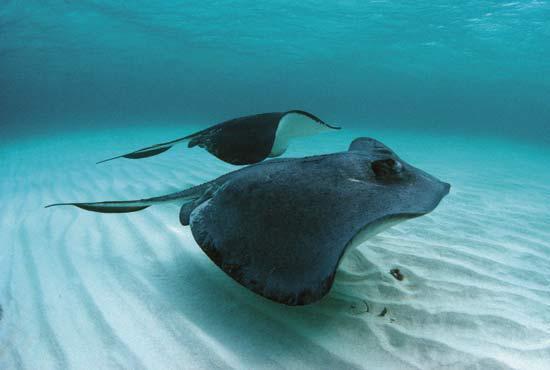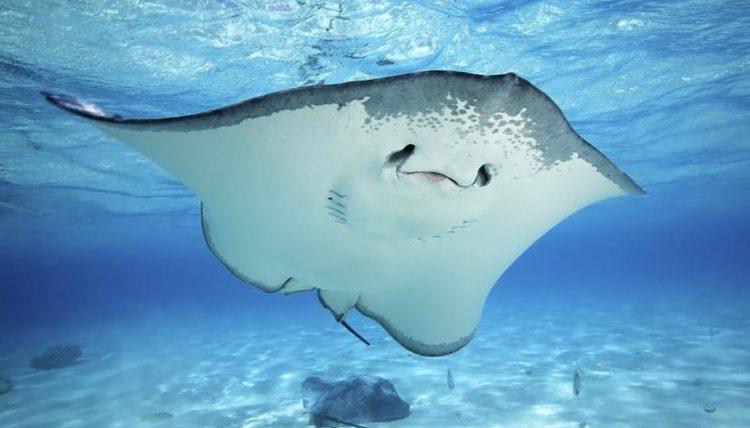The first image is the image on the left, the second image is the image on the right. Examine the images to the left and right. Is the description "Each image has exactly one ray." accurate? Answer yes or no. No. 